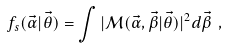Convert formula to latex. <formula><loc_0><loc_0><loc_500><loc_500>f _ { s } ( \vec { \alpha } | \vec { \theta } ) = \int | { \mathcal { M } } ( \vec { \alpha } , \vec { \beta } | \vec { \theta } ) | ^ { 2 } d \vec { \beta } \ ,</formula> 